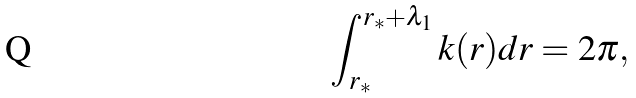Convert formula to latex. <formula><loc_0><loc_0><loc_500><loc_500>\int _ { r _ { * } } ^ { r _ { * } + \lambda _ { 1 } } k ( r ) d r = 2 \pi ,</formula> 